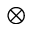Convert formula to latex. <formula><loc_0><loc_0><loc_500><loc_500>\otimes</formula> 